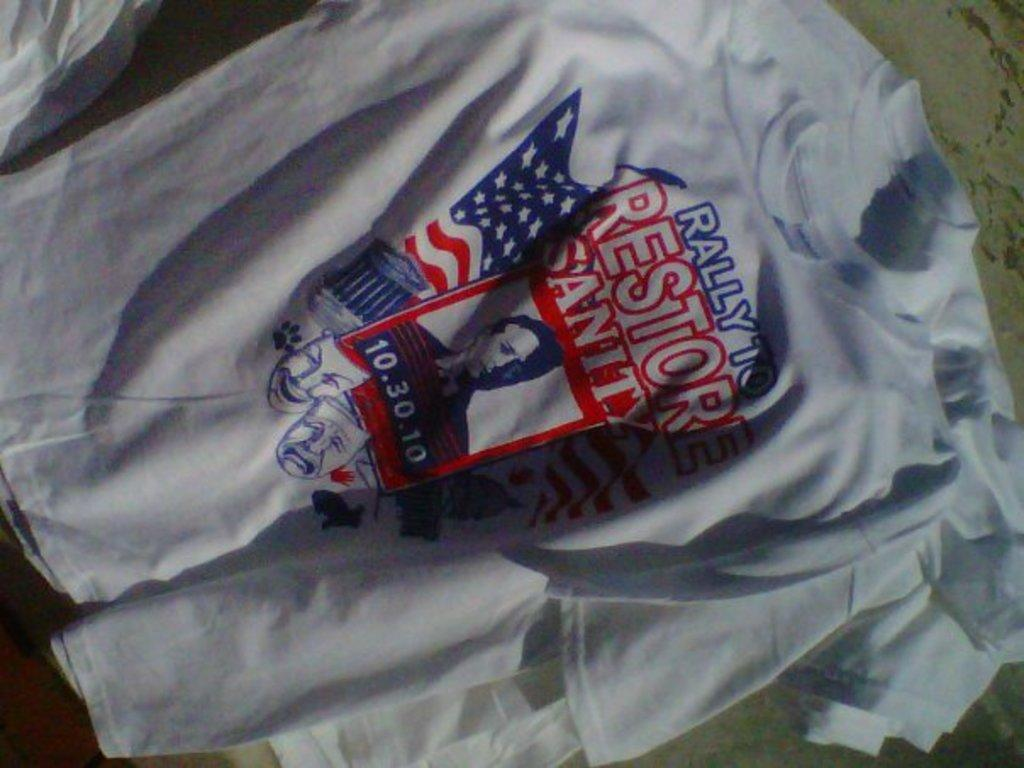<image>
Share a concise interpretation of the image provided. a shirt that has the word restore on it 